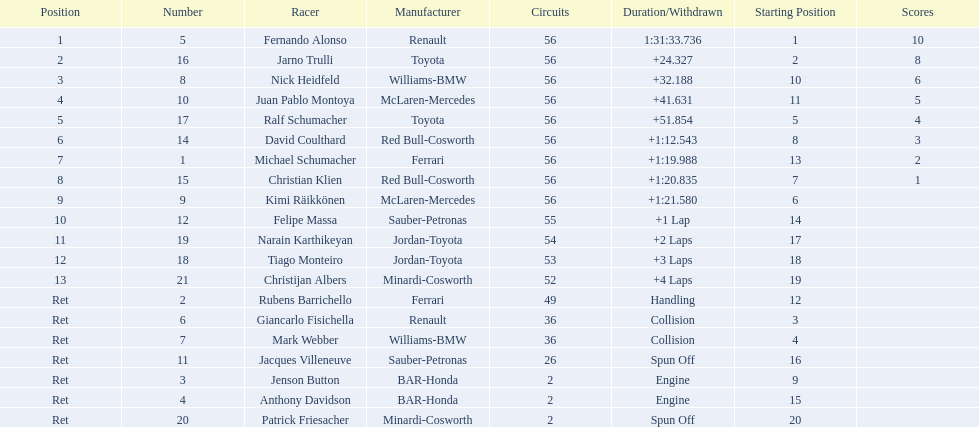Who raced during the 2005 malaysian grand prix? Fernando Alonso, Jarno Trulli, Nick Heidfeld, Juan Pablo Montoya, Ralf Schumacher, David Coulthard, Michael Schumacher, Christian Klien, Kimi Räikkönen, Felipe Massa, Narain Karthikeyan, Tiago Monteiro, Christijan Albers, Rubens Barrichello, Giancarlo Fisichella, Mark Webber, Jacques Villeneuve, Jenson Button, Anthony Davidson, Patrick Friesacher. What were their finishing times? 1:31:33.736, +24.327, +32.188, +41.631, +51.854, +1:12.543, +1:19.988, +1:20.835, +1:21.580, +1 Lap, +2 Laps, +3 Laps, +4 Laps, Handling, Collision, Collision, Spun Off, Engine, Engine, Spun Off. What was fernando alonso's finishing time? 1:31:33.736. 